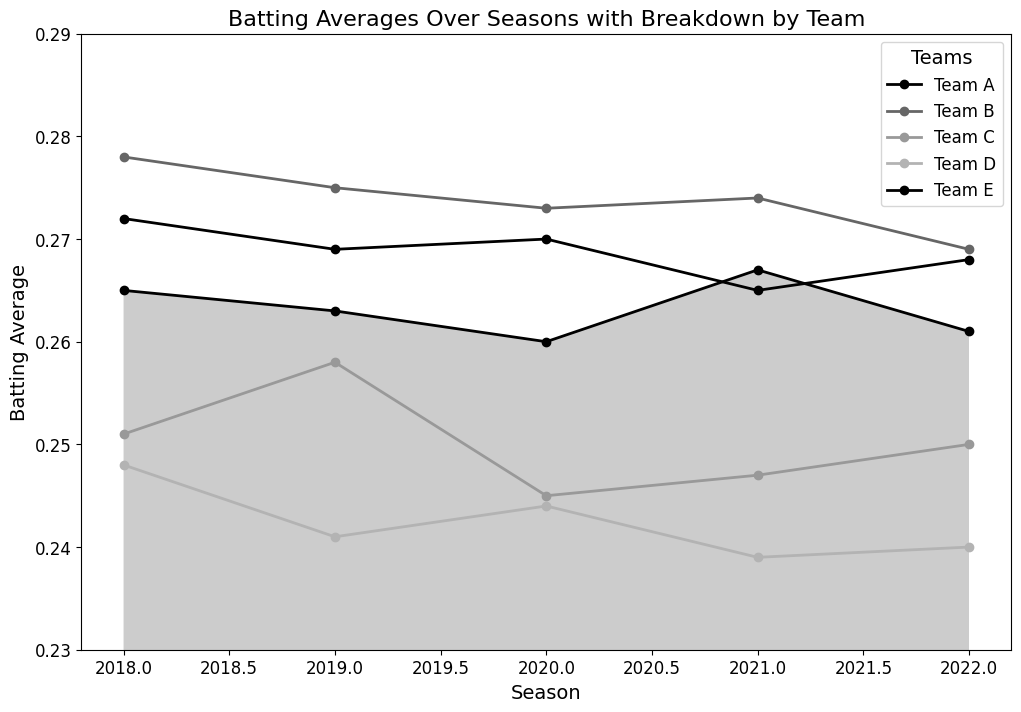What's the trend of Team A's batting average from the 2018 season to the 2022 season? Team A's batting average alternates around the 0.260 - 0.267 range, showing minor fluctuations. Looking at the data points: 2018: 0.265, 2019: 0.263, 2020: 0.260, 2021: 0.267, and 2022: 0.261, we can observe these small shifts up and down.
Answer: Minor fluctuations around the 0.260 - 0.267 range Which team had the highest batting average in the 2020 season? By comparing the batting averages of all teams in 2020: Team A: 0.260, Team B: 0.273, Team C: 0.245, Team D: 0.244, and Team E: 0.270, it is clear that Team B had the highest batting average.
Answer: Team B Which season had the lowest batting average for Team D? By analyzing Team D's batting average across the seasons: 2018: 0.248, 2019: 0.241, 2020: 0.244, 2021: 0.239, and 2022: 0.240, we see that the lowest was in 2021 at 0.239.
Answer: 2021 On average, which team performed better from 2018 to 2022? To find the average batting average for each team over the five seasons: 
Team A: (0.265 + 0.263 + 0.260 + 0.267 + 0.261) / 5 = 0.2632,
Team B: (0.278 + 0.275 + 0.273 + 0.274 + 0.269) / 5 = 0.2738,
Team C: (0.251 + 0.258 + 0.245 + 0.247 + 0.250) / 5 = 0.2502,
Team D: (0.248 + 0.241 + 0.244 + 0.239 + 0.240) / 5 = 0.2424,
Team E: (0.272 + 0.269 + 0.270 + 0.265 + 0.268) / 5 = 0.2688.
Team B has the highest average of 0.2738.
Answer: Team B Which teams had a visible decline in their batting average from 2018 to 2022? Observing the changes in batting averages between 2018 and 2022 for each team: 
Team A: 0.265 to 0.261, 
Team B: 0.278 to 0.269, 
Team C: 0.251 to 0.250, 
Team D: 0.248 to 0.240, 
Team E: 0.272 to 0.268;
Teams B and D show a visible decline.
Answer: Team B, Team D What's the batting average difference between Team C and Team E in the 2021 season? From the data, Team C's average in 2021 is 0.247, and Team E's is 0.265. The difference is 0.265 - 0.247 = 0.018.
Answer: 0.018 Which team showed the most consistent batting average from 2018 to 2022? To determine consistency, we observe the spread of each team's batting average across the seasons: 
Team A: 0.265, 0.263, 0.260, 0.267, 0.261,
Team B: 0.278, 0.275, 0.273, 0.274, 0.269,
Team C: 0.251, 0.258, 0.245, 0.247, 0.250,
Team D: 0.248, 0.241, 0.244, 0.239, 0.240,
Team E: 0.272, 0.269, 0.270, 0.265, 0.268.
Team E's data points are very close to each other, indicating the most consistency.
Answer: Team E What's the average batting average of Team D across all seasons shown? Summing and averaging Team D’s batting averages: (0.248 + 0.241 + 0.244 + 0.239 + 0.240) / 5 = 1.212 / 5 = 0.2424.
Answer: 0.2424 Which team had the biggest drop in batting average between any two consecutive seasons? Observing the differences between consecutive seasons for each team: 
Team A: (0.265-0.263, 0.263-0.260, 0.260-0.267, 0.267-0.261),
Team B: (0.278-0.275, 0.275-0.273, 0.273-0.274, 0.274-0.269),
Team C: (0.251-0.258, 0.258-0.245, 0.245-0.247, 0.247-0.250),
Team D: (0.248-0.241, 0.241-0.244, 0.244-0.239, 0.239-0.240),
Team E: (0.272-0.269, 0.269-0.270, 0.270-0.265, 0.265-0.268).
Team A had the largest drop of -0.007 between 2020 and 2021.
Answer: Team A 